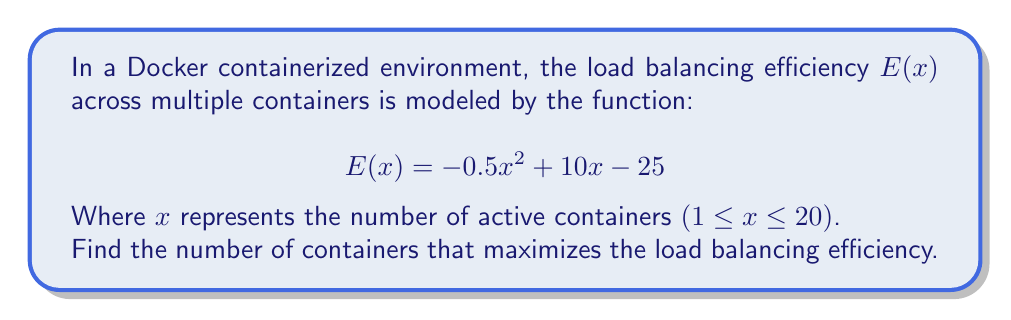Provide a solution to this math problem. To find the maximum efficiency point, we need to follow these steps:

1. The function $E(x)$ is a quadratic function, and its graph is a parabola. The maximum point occurs at the vertex of this parabola.

2. For a quadratic function in the form $f(x) = ax^2 + bx + c$, the x-coordinate of the vertex is given by $x = -\frac{b}{2a}$.

3. In our case, $a = -0.5$, $b = 10$, and $c = -25$. Let's substitute these values:

   $$x = -\frac{10}{2(-0.5)} = -\frac{10}{-1} = 10$$

4. To verify this is a maximum (not a minimum), we can check that $a < 0$, which it is ($a = -0.5$).

5. Since we're dealing with containers, we need to ensure our result is a whole number. Fortunately, 10 is already an integer.

6. We also need to check if this value falls within our given range (1 ≤ x ≤ 20). It does, as 10 is between 1 and 20.

Therefore, the number of containers that maximizes the load balancing efficiency is 10.
Answer: 10 containers 